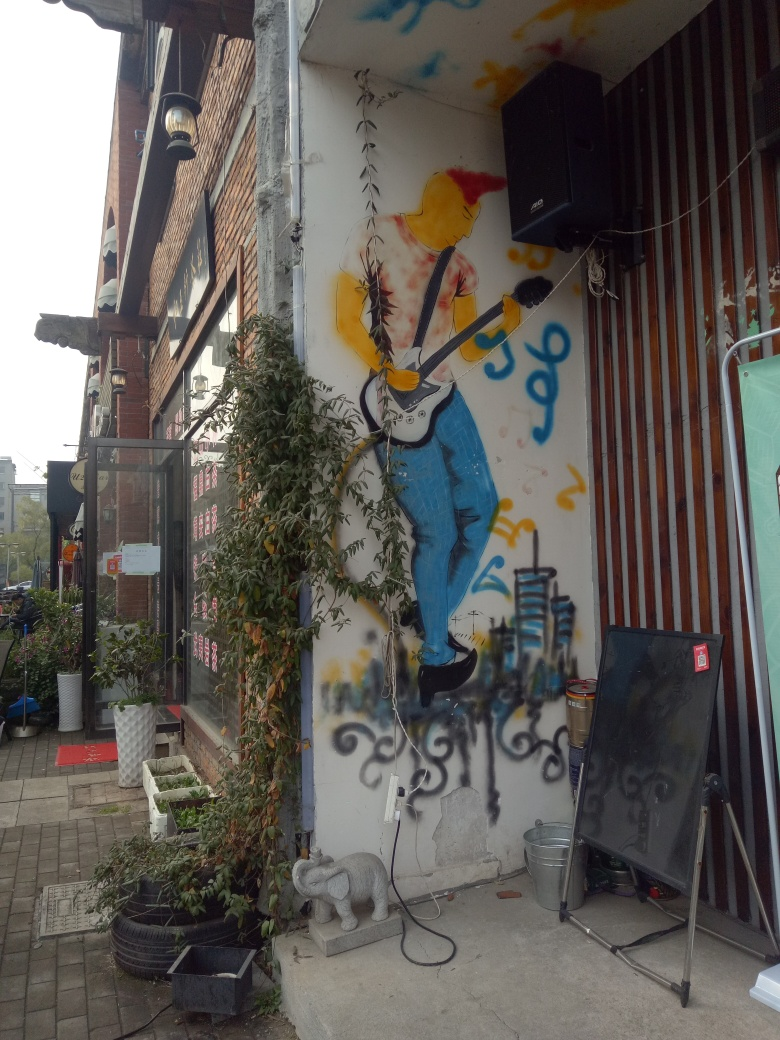What is the overall clarity of the image?
A. Moderate
B. Average
C. Very high
D. Low
Answer with the option's letter from the given choices directly.
 C. 